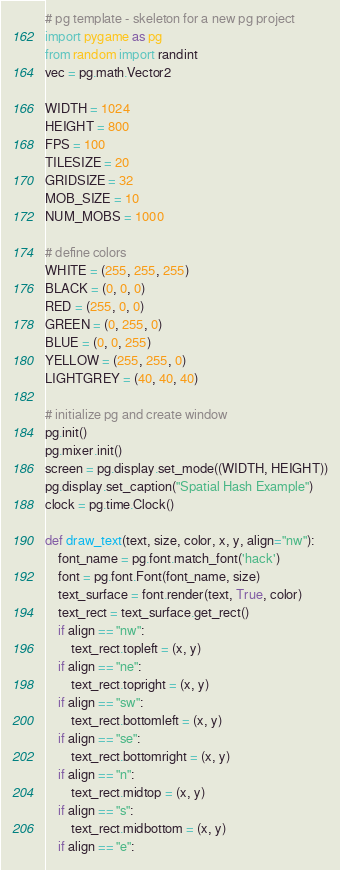<code> <loc_0><loc_0><loc_500><loc_500><_Python_># pg template - skeleton for a new pg project
import pygame as pg
from random import randint
vec = pg.math.Vector2

WIDTH = 1024
HEIGHT = 800
FPS = 100
TILESIZE = 20
GRIDSIZE = 32
MOB_SIZE = 10
NUM_MOBS = 1000

# define colors
WHITE = (255, 255, 255)
BLACK = (0, 0, 0)
RED = (255, 0, 0)
GREEN = (0, 255, 0)
BLUE = (0, 0, 255)
YELLOW = (255, 255, 0)
LIGHTGREY = (40, 40, 40)

# initialize pg and create window
pg.init()
pg.mixer.init()
screen = pg.display.set_mode((WIDTH, HEIGHT))
pg.display.set_caption("Spatial Hash Example")
clock = pg.time.Clock()

def draw_text(text, size, color, x, y, align="nw"):
    font_name = pg.font.match_font('hack')
    font = pg.font.Font(font_name, size)
    text_surface = font.render(text, True, color)
    text_rect = text_surface.get_rect()
    if align == "nw":
        text_rect.topleft = (x, y)
    if align == "ne":
        text_rect.topright = (x, y)
    if align == "sw":
        text_rect.bottomleft = (x, y)
    if align == "se":
        text_rect.bottomright = (x, y)
    if align == "n":
        text_rect.midtop = (x, y)
    if align == "s":
        text_rect.midbottom = (x, y)
    if align == "e":</code> 